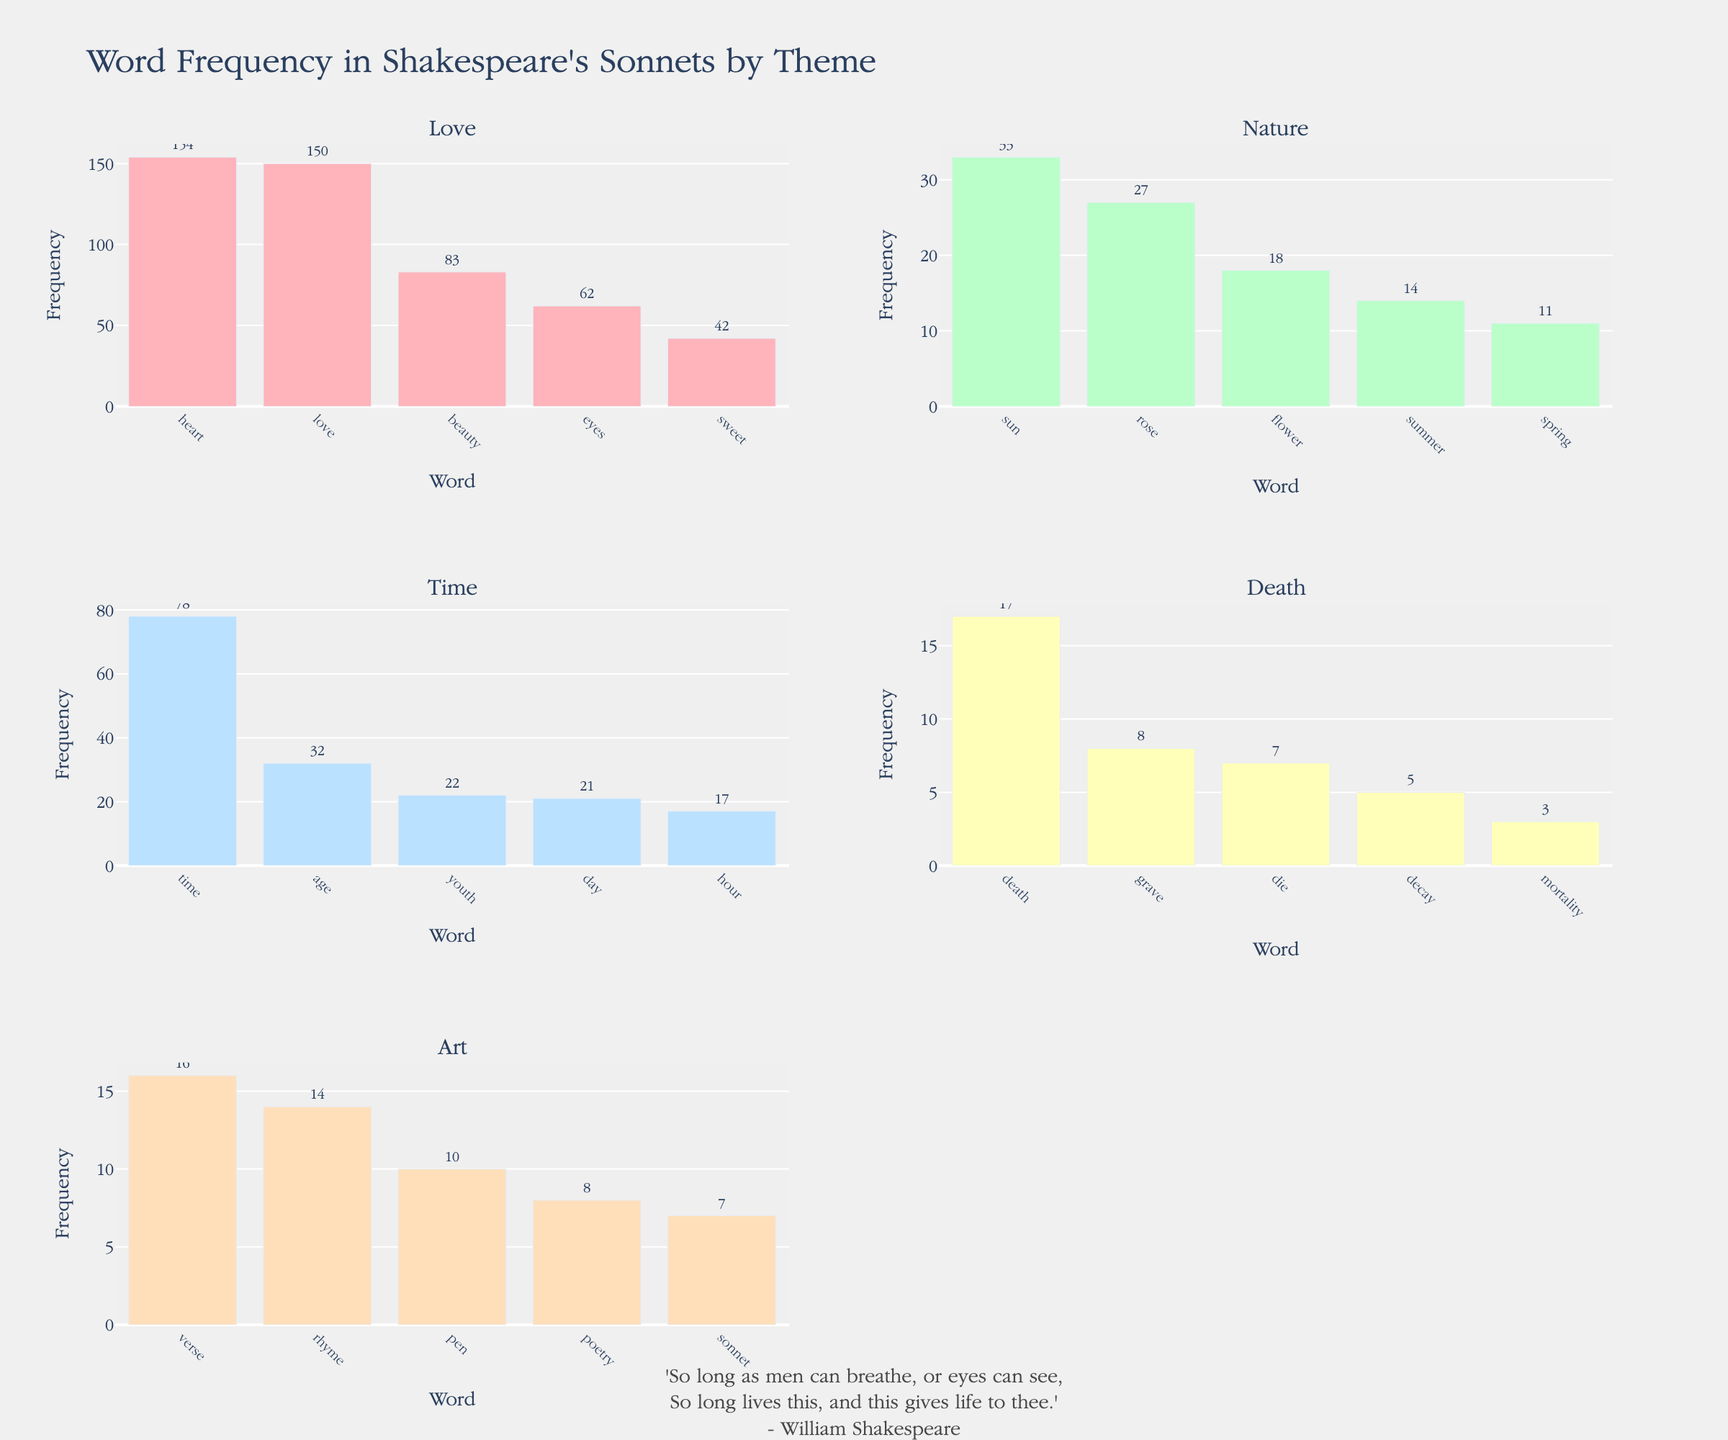What's the most frequently used word in the 'Love' theme? To determine this, look at the bar with the highest frequency in the 'Love' theme subplot. The word 'heart' appears most frequently with 154 occurrences.
Answer: heart Which theme has the lowest overall word frequency? To find this, add the frequencies for each word within all themes and compare. 'Death' has the lowest overall frequency with a total of 33 occurrences (17 + 8 + 7 + 5 + 3).
Answer: Death How many words have a frequency greater than 20 in the 'Time' theme? Observe the 'Time' theme subplot and count the bars where the frequency is greater than 20. The words 'time', 'age', and 'youth' meet this criterion, so there are 3 such words.
Answer: 3 What's the difference in frequency between 'rose' and 'spring' in the 'Nature' theme? In the 'Nature' theme, the frequency of 'rose' is 27 and 'spring' is 11. The difference is 27 - 11 = 16.
Answer: 16 Which word has the lowest frequency in the 'Death' theme? Look at the 'Death' theme subplot and identify the bar with the smallest frequency. The word 'mortality' has the lowest frequency with 3 occurrences.
Answer: mortality What is the most frequent word across all themes? Find the word with the highest frequency across all subplots. The word 'heart' in the 'Love' theme has the highest frequency with 154 occurrences.
Answer: heart How many themes have 'love' as one of the top words? Check if the word 'love' appears in more than one subplot. It appears only in the 'Love' theme.
Answer: 1 Which theme has the most words with frequencies between 10 and 20? Count the words with frequencies between 10 and 20 in each subplot. The 'Art' theme has three words ('verse', 'rhyme', 'pen') with frequencies between 10 and 20.
Answer: Art 